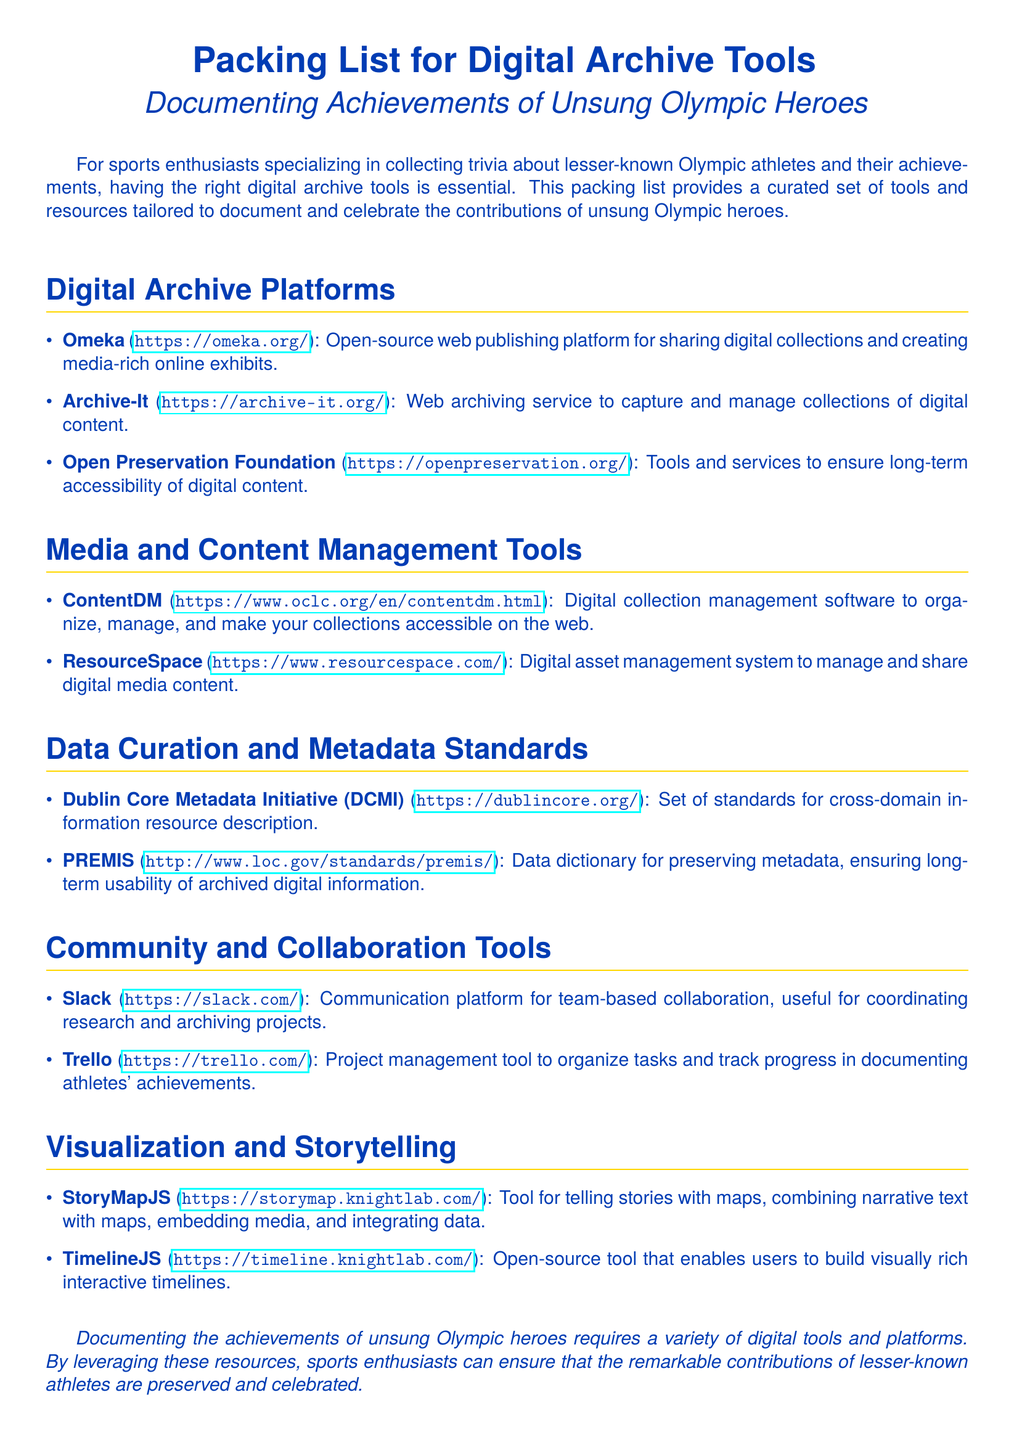What is the title of the document? The title of the document is provided prominently at the beginning, indicating its focus.
Answer: Packing List for Digital Archive Tools How many sections are in the document? The document contains multiple sections, each focusing on a specific type of tool.
Answer: 5 What is one of the digital archive platforms mentioned? The document lists various platforms designed for archiving, including some specific names.
Answer: Omeka Which tool is used for project management? The document includes specific tools for different functions, with one dedicated to project management.
Answer: Trello What is the website for the Dublin Core Metadata Initiative? Each resource listed includes its website for further exploration, including that for the Dublin Core.
Answer: https://dublincore.org/ Name one visualization tool mentioned. The document provides several tools for storytelling and visualization; one is specifically noted.
Answer: StoryMapJS What is the purpose of Archive-It? The purpose is described in the document and relates to managing digital content.
Answer: Web archiving service Which color is used for the document's theme? The document uses a specific color theme that is consistent throughout its formatting.
Answer: Olympic blue 